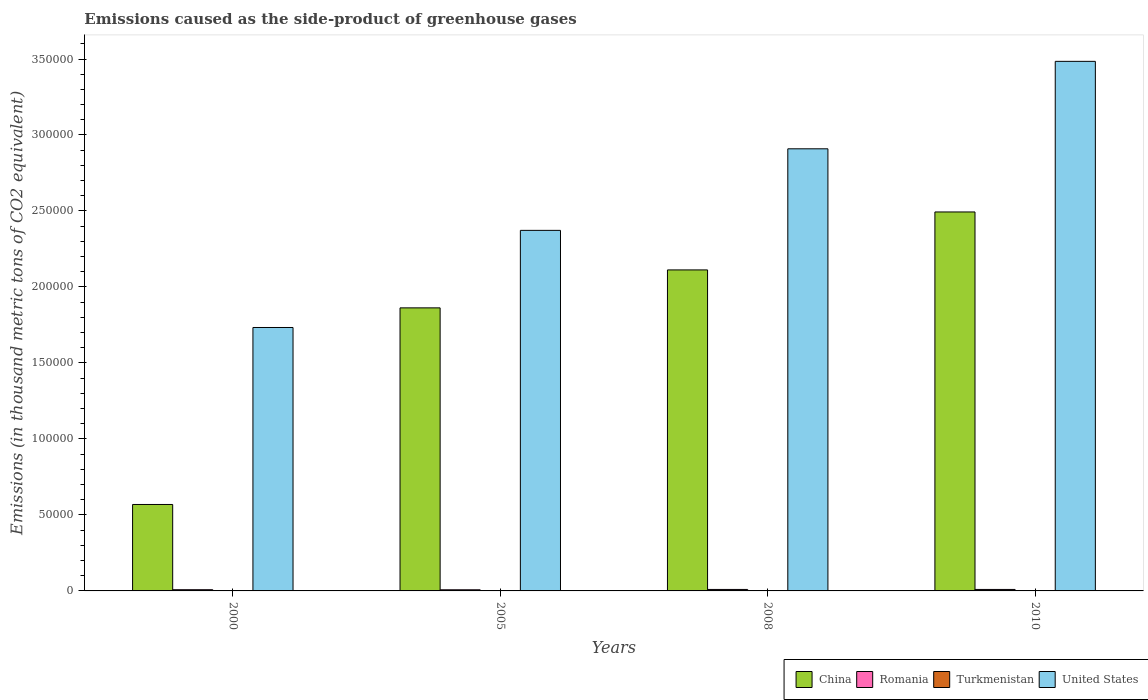How many groups of bars are there?
Make the answer very short. 4. Are the number of bars on each tick of the X-axis equal?
Give a very brief answer. Yes. What is the emissions caused as the side-product of greenhouse gases in United States in 2005?
Offer a very short reply. 2.37e+05. Across all years, what is the maximum emissions caused as the side-product of greenhouse gases in Turkmenistan?
Your answer should be very brief. 139. Across all years, what is the minimum emissions caused as the side-product of greenhouse gases in United States?
Offer a terse response. 1.73e+05. In which year was the emissions caused as the side-product of greenhouse gases in Romania minimum?
Give a very brief answer. 2005. What is the total emissions caused as the side-product of greenhouse gases in United States in the graph?
Provide a succinct answer. 1.05e+06. What is the difference between the emissions caused as the side-product of greenhouse gases in United States in 2000 and that in 2010?
Offer a very short reply. -1.75e+05. What is the difference between the emissions caused as the side-product of greenhouse gases in Romania in 2000 and the emissions caused as the side-product of greenhouse gases in Turkmenistan in 2008?
Offer a very short reply. 682.9. What is the average emissions caused as the side-product of greenhouse gases in China per year?
Make the answer very short. 1.76e+05. In the year 2000, what is the difference between the emissions caused as the side-product of greenhouse gases in Romania and emissions caused as the side-product of greenhouse gases in Turkmenistan?
Provide a short and direct response. 784.2. What is the ratio of the emissions caused as the side-product of greenhouse gases in Romania in 2000 to that in 2005?
Provide a short and direct response. 1.07. Is the emissions caused as the side-product of greenhouse gases in China in 2000 less than that in 2005?
Your response must be concise. Yes. What is the difference between the highest and the second highest emissions caused as the side-product of greenhouse gases in China?
Offer a very short reply. 3.81e+04. What is the difference between the highest and the lowest emissions caused as the side-product of greenhouse gases in United States?
Make the answer very short. 1.75e+05. Is it the case that in every year, the sum of the emissions caused as the side-product of greenhouse gases in China and emissions caused as the side-product of greenhouse gases in United States is greater than the sum of emissions caused as the side-product of greenhouse gases in Romania and emissions caused as the side-product of greenhouse gases in Turkmenistan?
Provide a short and direct response. Yes. What does the 1st bar from the left in 2008 represents?
Give a very brief answer. China. Does the graph contain any zero values?
Make the answer very short. No. Does the graph contain grids?
Your answer should be compact. No. How many legend labels are there?
Your answer should be compact. 4. How are the legend labels stacked?
Your answer should be compact. Horizontal. What is the title of the graph?
Your response must be concise. Emissions caused as the side-product of greenhouse gases. What is the label or title of the Y-axis?
Your response must be concise. Emissions (in thousand metric tons of CO2 equivalent). What is the Emissions (in thousand metric tons of CO2 equivalent) in China in 2000?
Ensure brevity in your answer.  5.69e+04. What is the Emissions (in thousand metric tons of CO2 equivalent) of Romania in 2000?
Your response must be concise. 795.1. What is the Emissions (in thousand metric tons of CO2 equivalent) in United States in 2000?
Make the answer very short. 1.73e+05. What is the Emissions (in thousand metric tons of CO2 equivalent) of China in 2005?
Offer a terse response. 1.86e+05. What is the Emissions (in thousand metric tons of CO2 equivalent) in Romania in 2005?
Provide a succinct answer. 742.3. What is the Emissions (in thousand metric tons of CO2 equivalent) in Turkmenistan in 2005?
Provide a succinct answer. 72.9. What is the Emissions (in thousand metric tons of CO2 equivalent) of United States in 2005?
Keep it short and to the point. 2.37e+05. What is the Emissions (in thousand metric tons of CO2 equivalent) of China in 2008?
Your response must be concise. 2.11e+05. What is the Emissions (in thousand metric tons of CO2 equivalent) of Romania in 2008?
Provide a short and direct response. 970.3. What is the Emissions (in thousand metric tons of CO2 equivalent) in Turkmenistan in 2008?
Your response must be concise. 112.2. What is the Emissions (in thousand metric tons of CO2 equivalent) of United States in 2008?
Provide a short and direct response. 2.91e+05. What is the Emissions (in thousand metric tons of CO2 equivalent) in China in 2010?
Offer a very short reply. 2.49e+05. What is the Emissions (in thousand metric tons of CO2 equivalent) of Romania in 2010?
Give a very brief answer. 975. What is the Emissions (in thousand metric tons of CO2 equivalent) of Turkmenistan in 2010?
Your answer should be compact. 139. What is the Emissions (in thousand metric tons of CO2 equivalent) of United States in 2010?
Your answer should be compact. 3.48e+05. Across all years, what is the maximum Emissions (in thousand metric tons of CO2 equivalent) in China?
Give a very brief answer. 2.49e+05. Across all years, what is the maximum Emissions (in thousand metric tons of CO2 equivalent) of Romania?
Provide a succinct answer. 975. Across all years, what is the maximum Emissions (in thousand metric tons of CO2 equivalent) of Turkmenistan?
Ensure brevity in your answer.  139. Across all years, what is the maximum Emissions (in thousand metric tons of CO2 equivalent) in United States?
Give a very brief answer. 3.48e+05. Across all years, what is the minimum Emissions (in thousand metric tons of CO2 equivalent) in China?
Ensure brevity in your answer.  5.69e+04. Across all years, what is the minimum Emissions (in thousand metric tons of CO2 equivalent) of Romania?
Your answer should be very brief. 742.3. Across all years, what is the minimum Emissions (in thousand metric tons of CO2 equivalent) in Turkmenistan?
Offer a terse response. 10.9. Across all years, what is the minimum Emissions (in thousand metric tons of CO2 equivalent) of United States?
Your answer should be compact. 1.73e+05. What is the total Emissions (in thousand metric tons of CO2 equivalent) in China in the graph?
Your answer should be very brief. 7.04e+05. What is the total Emissions (in thousand metric tons of CO2 equivalent) of Romania in the graph?
Give a very brief answer. 3482.7. What is the total Emissions (in thousand metric tons of CO2 equivalent) of Turkmenistan in the graph?
Your answer should be very brief. 335. What is the total Emissions (in thousand metric tons of CO2 equivalent) in United States in the graph?
Your answer should be very brief. 1.05e+06. What is the difference between the Emissions (in thousand metric tons of CO2 equivalent) of China in 2000 and that in 2005?
Ensure brevity in your answer.  -1.29e+05. What is the difference between the Emissions (in thousand metric tons of CO2 equivalent) in Romania in 2000 and that in 2005?
Your answer should be very brief. 52.8. What is the difference between the Emissions (in thousand metric tons of CO2 equivalent) of Turkmenistan in 2000 and that in 2005?
Provide a succinct answer. -62. What is the difference between the Emissions (in thousand metric tons of CO2 equivalent) of United States in 2000 and that in 2005?
Ensure brevity in your answer.  -6.39e+04. What is the difference between the Emissions (in thousand metric tons of CO2 equivalent) of China in 2000 and that in 2008?
Make the answer very short. -1.54e+05. What is the difference between the Emissions (in thousand metric tons of CO2 equivalent) in Romania in 2000 and that in 2008?
Ensure brevity in your answer.  -175.2. What is the difference between the Emissions (in thousand metric tons of CO2 equivalent) of Turkmenistan in 2000 and that in 2008?
Provide a short and direct response. -101.3. What is the difference between the Emissions (in thousand metric tons of CO2 equivalent) of United States in 2000 and that in 2008?
Keep it short and to the point. -1.18e+05. What is the difference between the Emissions (in thousand metric tons of CO2 equivalent) in China in 2000 and that in 2010?
Offer a terse response. -1.92e+05. What is the difference between the Emissions (in thousand metric tons of CO2 equivalent) of Romania in 2000 and that in 2010?
Your answer should be compact. -179.9. What is the difference between the Emissions (in thousand metric tons of CO2 equivalent) of Turkmenistan in 2000 and that in 2010?
Offer a very short reply. -128.1. What is the difference between the Emissions (in thousand metric tons of CO2 equivalent) in United States in 2000 and that in 2010?
Offer a terse response. -1.75e+05. What is the difference between the Emissions (in thousand metric tons of CO2 equivalent) of China in 2005 and that in 2008?
Your answer should be compact. -2.50e+04. What is the difference between the Emissions (in thousand metric tons of CO2 equivalent) in Romania in 2005 and that in 2008?
Provide a short and direct response. -228. What is the difference between the Emissions (in thousand metric tons of CO2 equivalent) in Turkmenistan in 2005 and that in 2008?
Provide a succinct answer. -39.3. What is the difference between the Emissions (in thousand metric tons of CO2 equivalent) in United States in 2005 and that in 2008?
Keep it short and to the point. -5.37e+04. What is the difference between the Emissions (in thousand metric tons of CO2 equivalent) of China in 2005 and that in 2010?
Provide a short and direct response. -6.31e+04. What is the difference between the Emissions (in thousand metric tons of CO2 equivalent) in Romania in 2005 and that in 2010?
Keep it short and to the point. -232.7. What is the difference between the Emissions (in thousand metric tons of CO2 equivalent) in Turkmenistan in 2005 and that in 2010?
Offer a terse response. -66.1. What is the difference between the Emissions (in thousand metric tons of CO2 equivalent) in United States in 2005 and that in 2010?
Offer a very short reply. -1.11e+05. What is the difference between the Emissions (in thousand metric tons of CO2 equivalent) of China in 2008 and that in 2010?
Provide a succinct answer. -3.81e+04. What is the difference between the Emissions (in thousand metric tons of CO2 equivalent) in Turkmenistan in 2008 and that in 2010?
Give a very brief answer. -26.8. What is the difference between the Emissions (in thousand metric tons of CO2 equivalent) of United States in 2008 and that in 2010?
Give a very brief answer. -5.75e+04. What is the difference between the Emissions (in thousand metric tons of CO2 equivalent) in China in 2000 and the Emissions (in thousand metric tons of CO2 equivalent) in Romania in 2005?
Make the answer very short. 5.61e+04. What is the difference between the Emissions (in thousand metric tons of CO2 equivalent) in China in 2000 and the Emissions (in thousand metric tons of CO2 equivalent) in Turkmenistan in 2005?
Provide a succinct answer. 5.68e+04. What is the difference between the Emissions (in thousand metric tons of CO2 equivalent) of China in 2000 and the Emissions (in thousand metric tons of CO2 equivalent) of United States in 2005?
Give a very brief answer. -1.80e+05. What is the difference between the Emissions (in thousand metric tons of CO2 equivalent) of Romania in 2000 and the Emissions (in thousand metric tons of CO2 equivalent) of Turkmenistan in 2005?
Provide a succinct answer. 722.2. What is the difference between the Emissions (in thousand metric tons of CO2 equivalent) in Romania in 2000 and the Emissions (in thousand metric tons of CO2 equivalent) in United States in 2005?
Give a very brief answer. -2.36e+05. What is the difference between the Emissions (in thousand metric tons of CO2 equivalent) in Turkmenistan in 2000 and the Emissions (in thousand metric tons of CO2 equivalent) in United States in 2005?
Keep it short and to the point. -2.37e+05. What is the difference between the Emissions (in thousand metric tons of CO2 equivalent) of China in 2000 and the Emissions (in thousand metric tons of CO2 equivalent) of Romania in 2008?
Your answer should be very brief. 5.59e+04. What is the difference between the Emissions (in thousand metric tons of CO2 equivalent) in China in 2000 and the Emissions (in thousand metric tons of CO2 equivalent) in Turkmenistan in 2008?
Ensure brevity in your answer.  5.68e+04. What is the difference between the Emissions (in thousand metric tons of CO2 equivalent) of China in 2000 and the Emissions (in thousand metric tons of CO2 equivalent) of United States in 2008?
Provide a succinct answer. -2.34e+05. What is the difference between the Emissions (in thousand metric tons of CO2 equivalent) of Romania in 2000 and the Emissions (in thousand metric tons of CO2 equivalent) of Turkmenistan in 2008?
Ensure brevity in your answer.  682.9. What is the difference between the Emissions (in thousand metric tons of CO2 equivalent) in Romania in 2000 and the Emissions (in thousand metric tons of CO2 equivalent) in United States in 2008?
Provide a short and direct response. -2.90e+05. What is the difference between the Emissions (in thousand metric tons of CO2 equivalent) of Turkmenistan in 2000 and the Emissions (in thousand metric tons of CO2 equivalent) of United States in 2008?
Your answer should be very brief. -2.91e+05. What is the difference between the Emissions (in thousand metric tons of CO2 equivalent) of China in 2000 and the Emissions (in thousand metric tons of CO2 equivalent) of Romania in 2010?
Keep it short and to the point. 5.59e+04. What is the difference between the Emissions (in thousand metric tons of CO2 equivalent) in China in 2000 and the Emissions (in thousand metric tons of CO2 equivalent) in Turkmenistan in 2010?
Offer a terse response. 5.67e+04. What is the difference between the Emissions (in thousand metric tons of CO2 equivalent) in China in 2000 and the Emissions (in thousand metric tons of CO2 equivalent) in United States in 2010?
Ensure brevity in your answer.  -2.92e+05. What is the difference between the Emissions (in thousand metric tons of CO2 equivalent) of Romania in 2000 and the Emissions (in thousand metric tons of CO2 equivalent) of Turkmenistan in 2010?
Your answer should be very brief. 656.1. What is the difference between the Emissions (in thousand metric tons of CO2 equivalent) in Romania in 2000 and the Emissions (in thousand metric tons of CO2 equivalent) in United States in 2010?
Your answer should be very brief. -3.48e+05. What is the difference between the Emissions (in thousand metric tons of CO2 equivalent) of Turkmenistan in 2000 and the Emissions (in thousand metric tons of CO2 equivalent) of United States in 2010?
Ensure brevity in your answer.  -3.48e+05. What is the difference between the Emissions (in thousand metric tons of CO2 equivalent) in China in 2005 and the Emissions (in thousand metric tons of CO2 equivalent) in Romania in 2008?
Offer a terse response. 1.85e+05. What is the difference between the Emissions (in thousand metric tons of CO2 equivalent) in China in 2005 and the Emissions (in thousand metric tons of CO2 equivalent) in Turkmenistan in 2008?
Offer a very short reply. 1.86e+05. What is the difference between the Emissions (in thousand metric tons of CO2 equivalent) in China in 2005 and the Emissions (in thousand metric tons of CO2 equivalent) in United States in 2008?
Your answer should be very brief. -1.05e+05. What is the difference between the Emissions (in thousand metric tons of CO2 equivalent) of Romania in 2005 and the Emissions (in thousand metric tons of CO2 equivalent) of Turkmenistan in 2008?
Your answer should be compact. 630.1. What is the difference between the Emissions (in thousand metric tons of CO2 equivalent) of Romania in 2005 and the Emissions (in thousand metric tons of CO2 equivalent) of United States in 2008?
Keep it short and to the point. -2.90e+05. What is the difference between the Emissions (in thousand metric tons of CO2 equivalent) in Turkmenistan in 2005 and the Emissions (in thousand metric tons of CO2 equivalent) in United States in 2008?
Provide a short and direct response. -2.91e+05. What is the difference between the Emissions (in thousand metric tons of CO2 equivalent) in China in 2005 and the Emissions (in thousand metric tons of CO2 equivalent) in Romania in 2010?
Offer a very short reply. 1.85e+05. What is the difference between the Emissions (in thousand metric tons of CO2 equivalent) in China in 2005 and the Emissions (in thousand metric tons of CO2 equivalent) in Turkmenistan in 2010?
Your answer should be very brief. 1.86e+05. What is the difference between the Emissions (in thousand metric tons of CO2 equivalent) of China in 2005 and the Emissions (in thousand metric tons of CO2 equivalent) of United States in 2010?
Offer a terse response. -1.62e+05. What is the difference between the Emissions (in thousand metric tons of CO2 equivalent) in Romania in 2005 and the Emissions (in thousand metric tons of CO2 equivalent) in Turkmenistan in 2010?
Ensure brevity in your answer.  603.3. What is the difference between the Emissions (in thousand metric tons of CO2 equivalent) in Romania in 2005 and the Emissions (in thousand metric tons of CO2 equivalent) in United States in 2010?
Make the answer very short. -3.48e+05. What is the difference between the Emissions (in thousand metric tons of CO2 equivalent) in Turkmenistan in 2005 and the Emissions (in thousand metric tons of CO2 equivalent) in United States in 2010?
Your answer should be compact. -3.48e+05. What is the difference between the Emissions (in thousand metric tons of CO2 equivalent) of China in 2008 and the Emissions (in thousand metric tons of CO2 equivalent) of Romania in 2010?
Your answer should be very brief. 2.10e+05. What is the difference between the Emissions (in thousand metric tons of CO2 equivalent) in China in 2008 and the Emissions (in thousand metric tons of CO2 equivalent) in Turkmenistan in 2010?
Offer a very short reply. 2.11e+05. What is the difference between the Emissions (in thousand metric tons of CO2 equivalent) in China in 2008 and the Emissions (in thousand metric tons of CO2 equivalent) in United States in 2010?
Offer a very short reply. -1.37e+05. What is the difference between the Emissions (in thousand metric tons of CO2 equivalent) in Romania in 2008 and the Emissions (in thousand metric tons of CO2 equivalent) in Turkmenistan in 2010?
Make the answer very short. 831.3. What is the difference between the Emissions (in thousand metric tons of CO2 equivalent) in Romania in 2008 and the Emissions (in thousand metric tons of CO2 equivalent) in United States in 2010?
Your answer should be very brief. -3.47e+05. What is the difference between the Emissions (in thousand metric tons of CO2 equivalent) of Turkmenistan in 2008 and the Emissions (in thousand metric tons of CO2 equivalent) of United States in 2010?
Make the answer very short. -3.48e+05. What is the average Emissions (in thousand metric tons of CO2 equivalent) in China per year?
Offer a very short reply. 1.76e+05. What is the average Emissions (in thousand metric tons of CO2 equivalent) of Romania per year?
Your response must be concise. 870.67. What is the average Emissions (in thousand metric tons of CO2 equivalent) of Turkmenistan per year?
Ensure brevity in your answer.  83.75. What is the average Emissions (in thousand metric tons of CO2 equivalent) in United States per year?
Offer a terse response. 2.62e+05. In the year 2000, what is the difference between the Emissions (in thousand metric tons of CO2 equivalent) in China and Emissions (in thousand metric tons of CO2 equivalent) in Romania?
Offer a very short reply. 5.61e+04. In the year 2000, what is the difference between the Emissions (in thousand metric tons of CO2 equivalent) in China and Emissions (in thousand metric tons of CO2 equivalent) in Turkmenistan?
Make the answer very short. 5.69e+04. In the year 2000, what is the difference between the Emissions (in thousand metric tons of CO2 equivalent) of China and Emissions (in thousand metric tons of CO2 equivalent) of United States?
Make the answer very short. -1.16e+05. In the year 2000, what is the difference between the Emissions (in thousand metric tons of CO2 equivalent) in Romania and Emissions (in thousand metric tons of CO2 equivalent) in Turkmenistan?
Make the answer very short. 784.2. In the year 2000, what is the difference between the Emissions (in thousand metric tons of CO2 equivalent) in Romania and Emissions (in thousand metric tons of CO2 equivalent) in United States?
Give a very brief answer. -1.73e+05. In the year 2000, what is the difference between the Emissions (in thousand metric tons of CO2 equivalent) of Turkmenistan and Emissions (in thousand metric tons of CO2 equivalent) of United States?
Your response must be concise. -1.73e+05. In the year 2005, what is the difference between the Emissions (in thousand metric tons of CO2 equivalent) of China and Emissions (in thousand metric tons of CO2 equivalent) of Romania?
Keep it short and to the point. 1.86e+05. In the year 2005, what is the difference between the Emissions (in thousand metric tons of CO2 equivalent) in China and Emissions (in thousand metric tons of CO2 equivalent) in Turkmenistan?
Your answer should be compact. 1.86e+05. In the year 2005, what is the difference between the Emissions (in thousand metric tons of CO2 equivalent) in China and Emissions (in thousand metric tons of CO2 equivalent) in United States?
Your response must be concise. -5.10e+04. In the year 2005, what is the difference between the Emissions (in thousand metric tons of CO2 equivalent) of Romania and Emissions (in thousand metric tons of CO2 equivalent) of Turkmenistan?
Keep it short and to the point. 669.4. In the year 2005, what is the difference between the Emissions (in thousand metric tons of CO2 equivalent) in Romania and Emissions (in thousand metric tons of CO2 equivalent) in United States?
Offer a very short reply. -2.37e+05. In the year 2005, what is the difference between the Emissions (in thousand metric tons of CO2 equivalent) in Turkmenistan and Emissions (in thousand metric tons of CO2 equivalent) in United States?
Provide a succinct answer. -2.37e+05. In the year 2008, what is the difference between the Emissions (in thousand metric tons of CO2 equivalent) in China and Emissions (in thousand metric tons of CO2 equivalent) in Romania?
Ensure brevity in your answer.  2.10e+05. In the year 2008, what is the difference between the Emissions (in thousand metric tons of CO2 equivalent) in China and Emissions (in thousand metric tons of CO2 equivalent) in Turkmenistan?
Your answer should be very brief. 2.11e+05. In the year 2008, what is the difference between the Emissions (in thousand metric tons of CO2 equivalent) in China and Emissions (in thousand metric tons of CO2 equivalent) in United States?
Make the answer very short. -7.97e+04. In the year 2008, what is the difference between the Emissions (in thousand metric tons of CO2 equivalent) in Romania and Emissions (in thousand metric tons of CO2 equivalent) in Turkmenistan?
Offer a terse response. 858.1. In the year 2008, what is the difference between the Emissions (in thousand metric tons of CO2 equivalent) of Romania and Emissions (in thousand metric tons of CO2 equivalent) of United States?
Offer a terse response. -2.90e+05. In the year 2008, what is the difference between the Emissions (in thousand metric tons of CO2 equivalent) of Turkmenistan and Emissions (in thousand metric tons of CO2 equivalent) of United States?
Provide a succinct answer. -2.91e+05. In the year 2010, what is the difference between the Emissions (in thousand metric tons of CO2 equivalent) of China and Emissions (in thousand metric tons of CO2 equivalent) of Romania?
Ensure brevity in your answer.  2.48e+05. In the year 2010, what is the difference between the Emissions (in thousand metric tons of CO2 equivalent) in China and Emissions (in thousand metric tons of CO2 equivalent) in Turkmenistan?
Your answer should be compact. 2.49e+05. In the year 2010, what is the difference between the Emissions (in thousand metric tons of CO2 equivalent) of China and Emissions (in thousand metric tons of CO2 equivalent) of United States?
Offer a terse response. -9.91e+04. In the year 2010, what is the difference between the Emissions (in thousand metric tons of CO2 equivalent) of Romania and Emissions (in thousand metric tons of CO2 equivalent) of Turkmenistan?
Offer a very short reply. 836. In the year 2010, what is the difference between the Emissions (in thousand metric tons of CO2 equivalent) of Romania and Emissions (in thousand metric tons of CO2 equivalent) of United States?
Your answer should be compact. -3.47e+05. In the year 2010, what is the difference between the Emissions (in thousand metric tons of CO2 equivalent) in Turkmenistan and Emissions (in thousand metric tons of CO2 equivalent) in United States?
Your answer should be very brief. -3.48e+05. What is the ratio of the Emissions (in thousand metric tons of CO2 equivalent) of China in 2000 to that in 2005?
Provide a succinct answer. 0.31. What is the ratio of the Emissions (in thousand metric tons of CO2 equivalent) in Romania in 2000 to that in 2005?
Your response must be concise. 1.07. What is the ratio of the Emissions (in thousand metric tons of CO2 equivalent) in Turkmenistan in 2000 to that in 2005?
Give a very brief answer. 0.15. What is the ratio of the Emissions (in thousand metric tons of CO2 equivalent) of United States in 2000 to that in 2005?
Ensure brevity in your answer.  0.73. What is the ratio of the Emissions (in thousand metric tons of CO2 equivalent) in China in 2000 to that in 2008?
Keep it short and to the point. 0.27. What is the ratio of the Emissions (in thousand metric tons of CO2 equivalent) in Romania in 2000 to that in 2008?
Give a very brief answer. 0.82. What is the ratio of the Emissions (in thousand metric tons of CO2 equivalent) in Turkmenistan in 2000 to that in 2008?
Your response must be concise. 0.1. What is the ratio of the Emissions (in thousand metric tons of CO2 equivalent) in United States in 2000 to that in 2008?
Ensure brevity in your answer.  0.6. What is the ratio of the Emissions (in thousand metric tons of CO2 equivalent) of China in 2000 to that in 2010?
Your answer should be very brief. 0.23. What is the ratio of the Emissions (in thousand metric tons of CO2 equivalent) in Romania in 2000 to that in 2010?
Give a very brief answer. 0.82. What is the ratio of the Emissions (in thousand metric tons of CO2 equivalent) of Turkmenistan in 2000 to that in 2010?
Provide a short and direct response. 0.08. What is the ratio of the Emissions (in thousand metric tons of CO2 equivalent) of United States in 2000 to that in 2010?
Make the answer very short. 0.5. What is the ratio of the Emissions (in thousand metric tons of CO2 equivalent) of China in 2005 to that in 2008?
Provide a short and direct response. 0.88. What is the ratio of the Emissions (in thousand metric tons of CO2 equivalent) of Romania in 2005 to that in 2008?
Your answer should be compact. 0.77. What is the ratio of the Emissions (in thousand metric tons of CO2 equivalent) of Turkmenistan in 2005 to that in 2008?
Ensure brevity in your answer.  0.65. What is the ratio of the Emissions (in thousand metric tons of CO2 equivalent) of United States in 2005 to that in 2008?
Offer a very short reply. 0.82. What is the ratio of the Emissions (in thousand metric tons of CO2 equivalent) in China in 2005 to that in 2010?
Provide a succinct answer. 0.75. What is the ratio of the Emissions (in thousand metric tons of CO2 equivalent) in Romania in 2005 to that in 2010?
Provide a succinct answer. 0.76. What is the ratio of the Emissions (in thousand metric tons of CO2 equivalent) of Turkmenistan in 2005 to that in 2010?
Provide a succinct answer. 0.52. What is the ratio of the Emissions (in thousand metric tons of CO2 equivalent) in United States in 2005 to that in 2010?
Provide a short and direct response. 0.68. What is the ratio of the Emissions (in thousand metric tons of CO2 equivalent) of China in 2008 to that in 2010?
Keep it short and to the point. 0.85. What is the ratio of the Emissions (in thousand metric tons of CO2 equivalent) in Romania in 2008 to that in 2010?
Give a very brief answer. 1. What is the ratio of the Emissions (in thousand metric tons of CO2 equivalent) of Turkmenistan in 2008 to that in 2010?
Make the answer very short. 0.81. What is the ratio of the Emissions (in thousand metric tons of CO2 equivalent) of United States in 2008 to that in 2010?
Make the answer very short. 0.83. What is the difference between the highest and the second highest Emissions (in thousand metric tons of CO2 equivalent) of China?
Ensure brevity in your answer.  3.81e+04. What is the difference between the highest and the second highest Emissions (in thousand metric tons of CO2 equivalent) in Turkmenistan?
Provide a succinct answer. 26.8. What is the difference between the highest and the second highest Emissions (in thousand metric tons of CO2 equivalent) of United States?
Ensure brevity in your answer.  5.75e+04. What is the difference between the highest and the lowest Emissions (in thousand metric tons of CO2 equivalent) of China?
Make the answer very short. 1.92e+05. What is the difference between the highest and the lowest Emissions (in thousand metric tons of CO2 equivalent) of Romania?
Your response must be concise. 232.7. What is the difference between the highest and the lowest Emissions (in thousand metric tons of CO2 equivalent) in Turkmenistan?
Give a very brief answer. 128.1. What is the difference between the highest and the lowest Emissions (in thousand metric tons of CO2 equivalent) in United States?
Provide a short and direct response. 1.75e+05. 